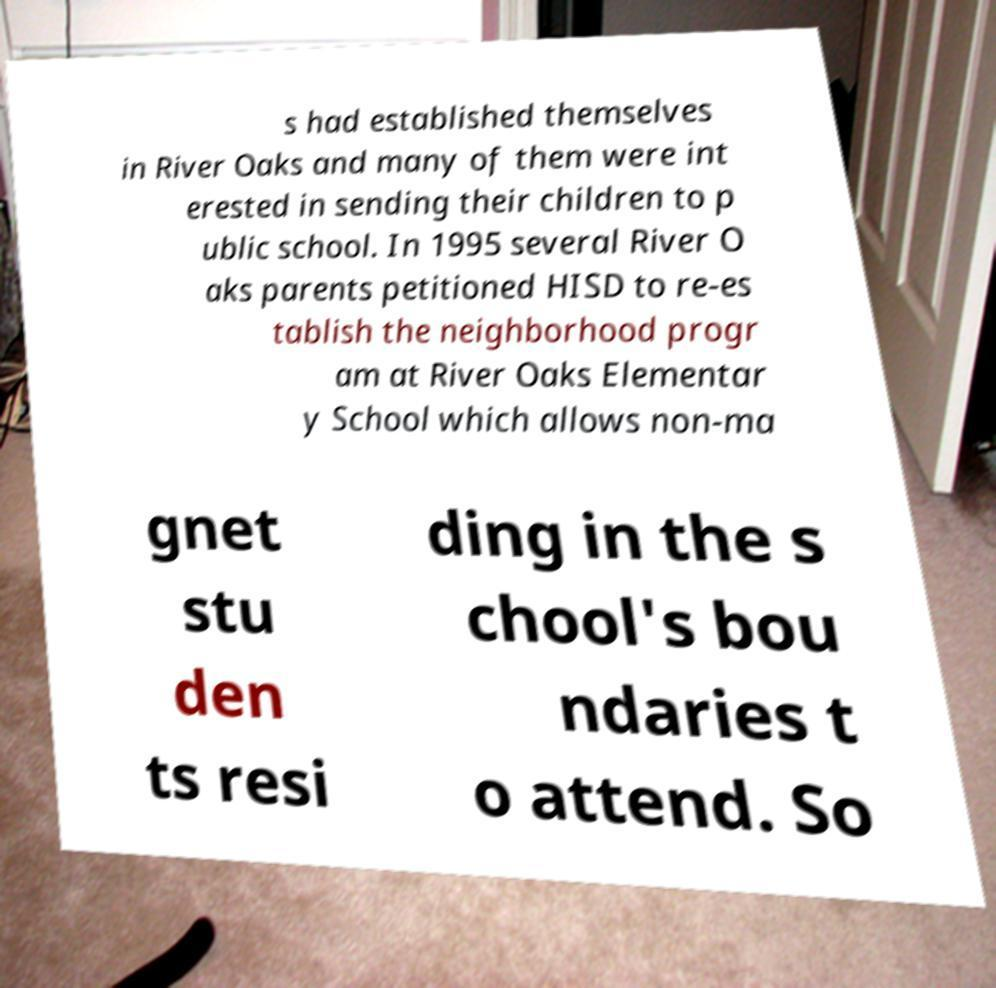Can you read and provide the text displayed in the image?This photo seems to have some interesting text. Can you extract and type it out for me? s had established themselves in River Oaks and many of them were int erested in sending their children to p ublic school. In 1995 several River O aks parents petitioned HISD to re-es tablish the neighborhood progr am at River Oaks Elementar y School which allows non-ma gnet stu den ts resi ding in the s chool's bou ndaries t o attend. So 